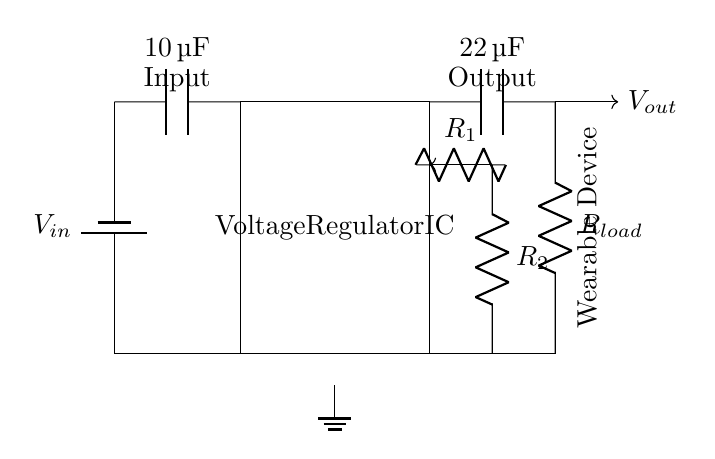What is the input capacitor value? The diagram shows a capacitor labeled with the value of ten microfarads, which is the input capacitor employed for smoothing the voltage from the power source.
Answer: ten microfarads What component regulates the voltage? The box labeled "Voltage Regulator IC" indicates that this is the component responsible for regulating the voltage output to maintain stability in the circuit.
Answer: Voltage Regulator IC What is the output capacitor value? The output capacitor is next to the output terminal and is labeled with the value of twenty-two microfarads, which helps in stabilizing the output voltage.
Answer: twenty-two microfarads What is the purpose of resistors R1 and R2? Resistors R1 and R2 are part of the feedback loop for the voltage regulator, used to set the output voltage level by dividing the voltage.
Answer: Set output voltage Which way does the output voltage flow in the circuit? The diagram shows an arrow indicating the output voltage flow moving away from the output capacitor towards the load resistor, demonstrating the direction of current flow in the circuit.
Answer: Right How does the circuit ground? The ground of the circuit is indicated with a ground symbol below the voltage regulator, connecting the circuit to the common reference point, essential for circuit operation and stability.
Answer: Voltage Regulator ground What is typically connected to the load resistor? The load resistor connects to the wearable device, receiving the regulated output voltage to power it, which is shown in the label on the right side of the output.
Answer: Wearable device 